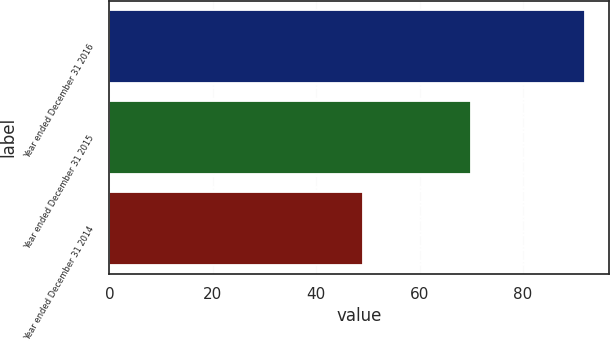<chart> <loc_0><loc_0><loc_500><loc_500><bar_chart><fcel>Year ended December 31 2016<fcel>Year ended December 31 2015<fcel>Year ended December 31 2014<nl><fcel>92<fcel>70<fcel>49<nl></chart> 